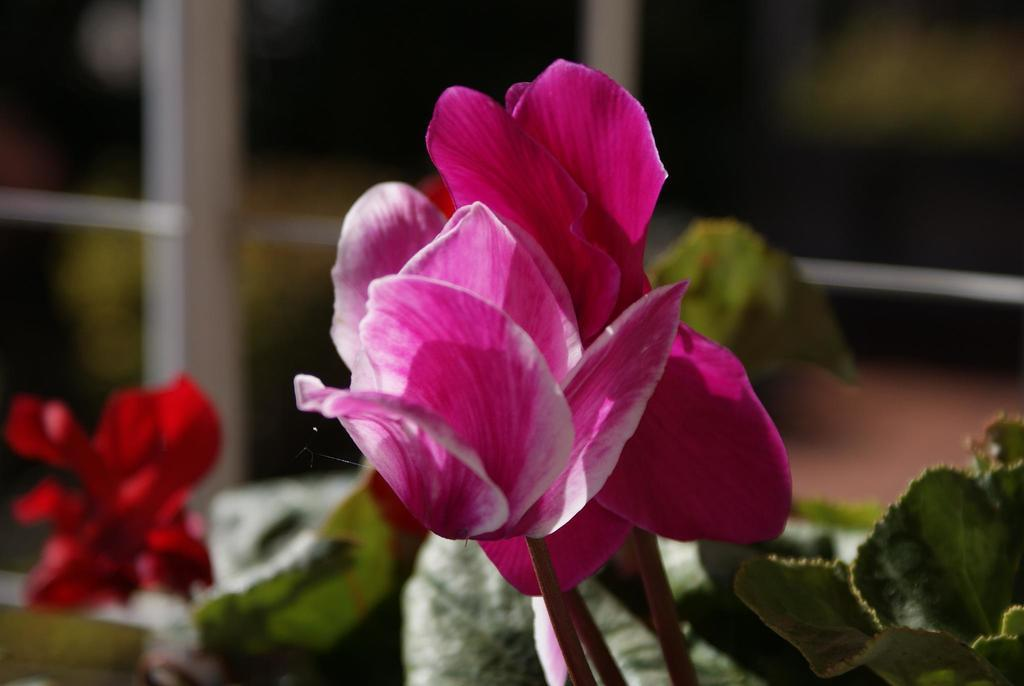What type of flower can be seen on a plant in the image? There is a pink flower on a plant in the image. Are there any other flowers visible in the image? Yes, there is another plant with a red flower in the image. Can you describe the background of the image? The background of the image is blurry. What type of dock can be seen in the image? There is no dock present in the image. What is the purpose of the stop sign in the image? There is no stop sign present in the image. 